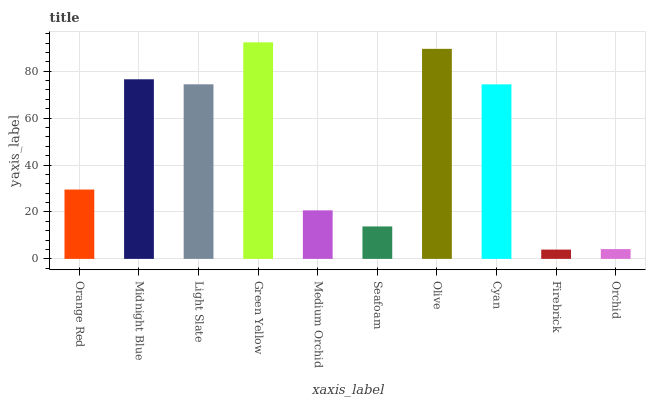Is Midnight Blue the minimum?
Answer yes or no. No. Is Midnight Blue the maximum?
Answer yes or no. No. Is Midnight Blue greater than Orange Red?
Answer yes or no. Yes. Is Orange Red less than Midnight Blue?
Answer yes or no. Yes. Is Orange Red greater than Midnight Blue?
Answer yes or no. No. Is Midnight Blue less than Orange Red?
Answer yes or no. No. Is Cyan the high median?
Answer yes or no. Yes. Is Orange Red the low median?
Answer yes or no. Yes. Is Olive the high median?
Answer yes or no. No. Is Green Yellow the low median?
Answer yes or no. No. 